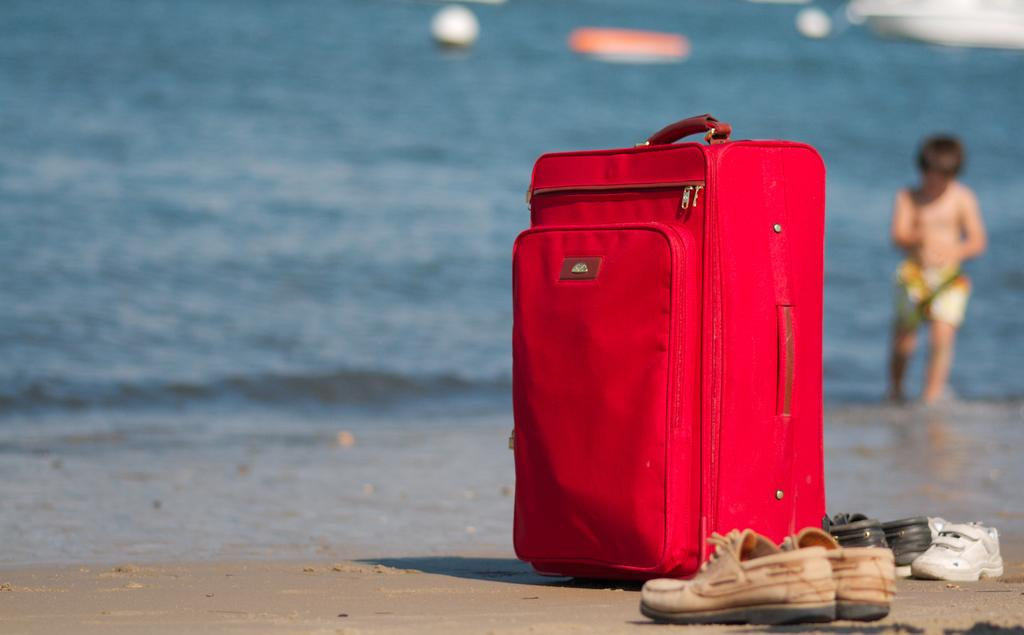What is the location of the image? The image is taken near a sea. What object can be seen on the floor in the image? There is a red bag placed on the floor. What type of footwear is visible in the image? There is a pair of shoes in the image. What activity is the kid engaged in the background? A kid is playing with water in the background. What time of day is it in the image, and how does the morning light affect the scene? The time of day is not mentioned in the facts provided, and there is no indication of morning light in the image. 